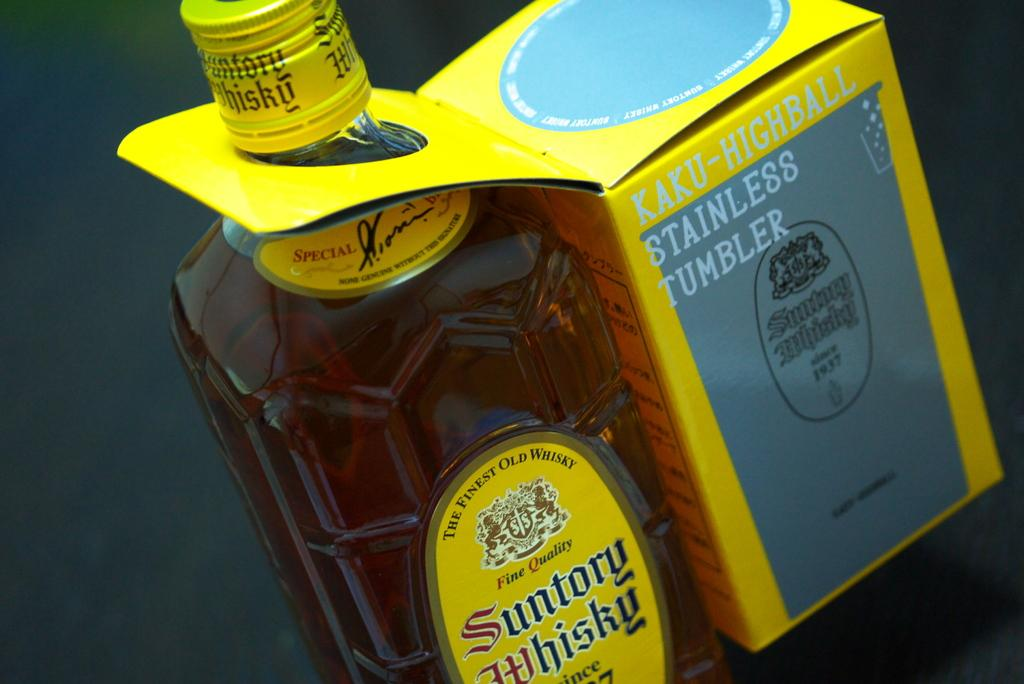<image>
Relay a brief, clear account of the picture shown. a bottle of Suntory Whisky with a Stainless Tumbler attached at the neck 